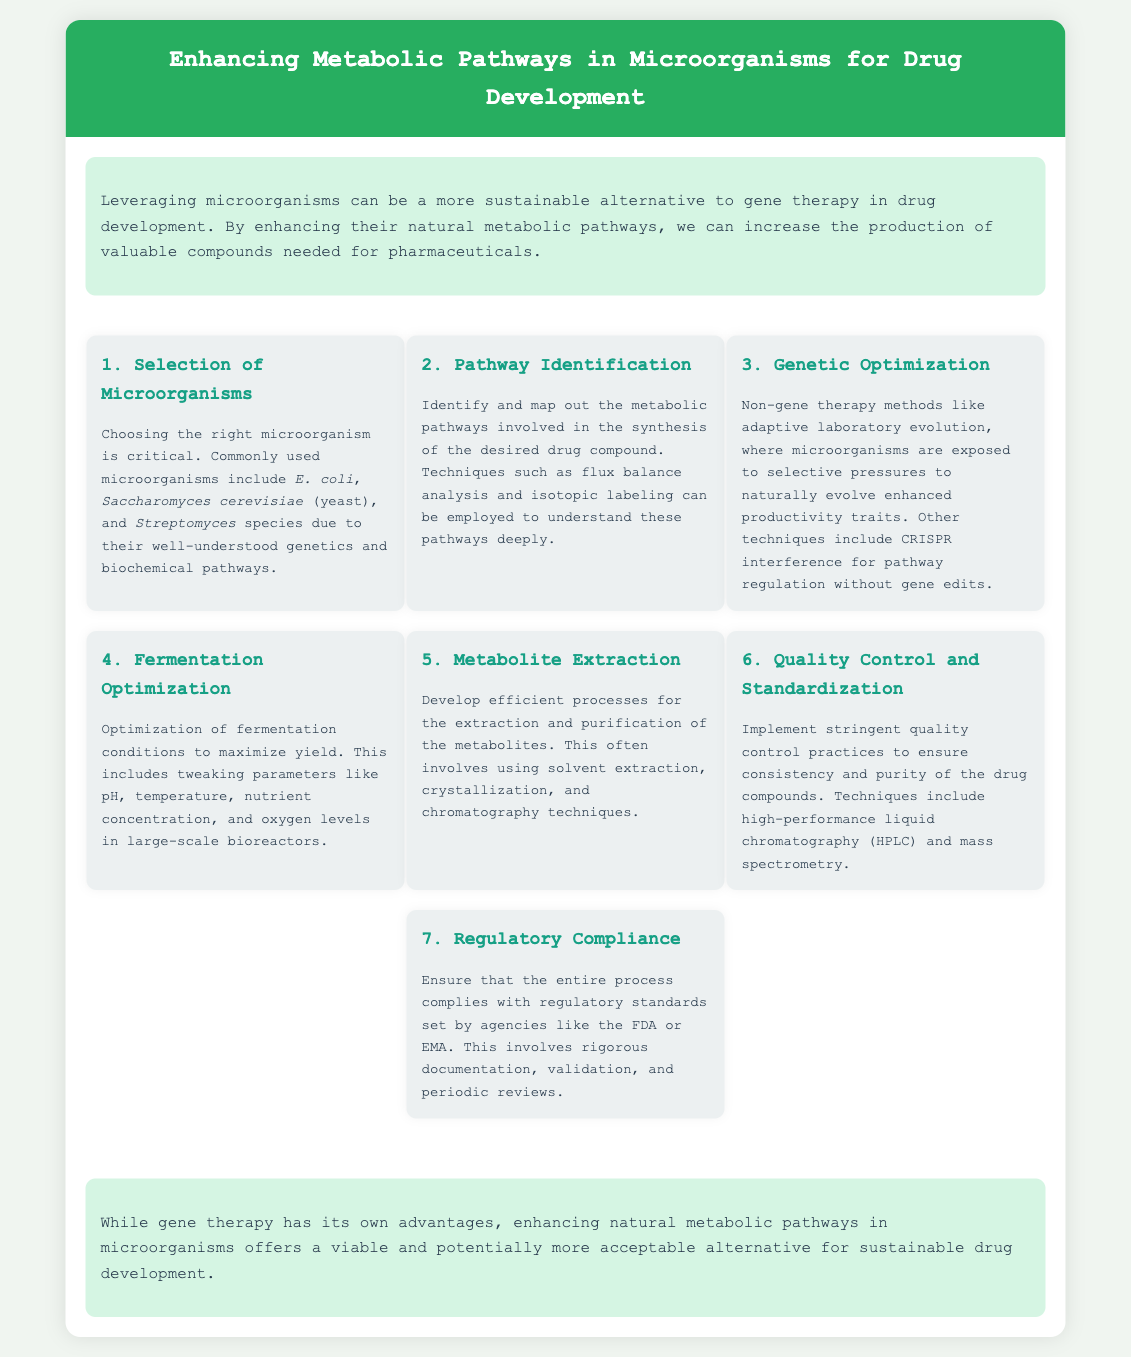What microorganisms are commonly used? The document mentions commonly used microorganisms, including Escherichia coli, Saccharomyces cerevisiae (yeast), and Streptomyces species.
Answer: E. coli, Saccharomyces cerevisiae, Streptomyces species What technique helps in pathway identification? The document states that techniques such as flux balance analysis and isotopic labeling can be used to understand metabolic pathways.
Answer: Flux balance analysis What is the first step in the process? The initial step outlined in the document is the selection of microorganisms.
Answer: Selection of Microorganisms What does genetic optimization include? Genetic optimization involves non-gene therapy methods, including adaptive laboratory evolution and CRISPR interference.
Answer: Adaptive laboratory evolution What is crucial for quality control? The document notes high-performance liquid chromatography (HPLC) and mass spectrometry as techniques important in quality control.
Answer: HPLC What does fermentation optimization maximize? The document indicates that fermentation optimization is aimed at maximizing yield, which refers to the output of the desired compounds.
Answer: Yield How many steps are outlined in the process? The document describes a total of seven steps in enhancing metabolic pathways for drug development.
Answer: Seven steps What is a potential alternative to gene therapy? The introduction of the document mentions enhancing natural metabolic pathways as a viable alternative to gene therapy.
Answer: Enhancing natural metabolic pathways 